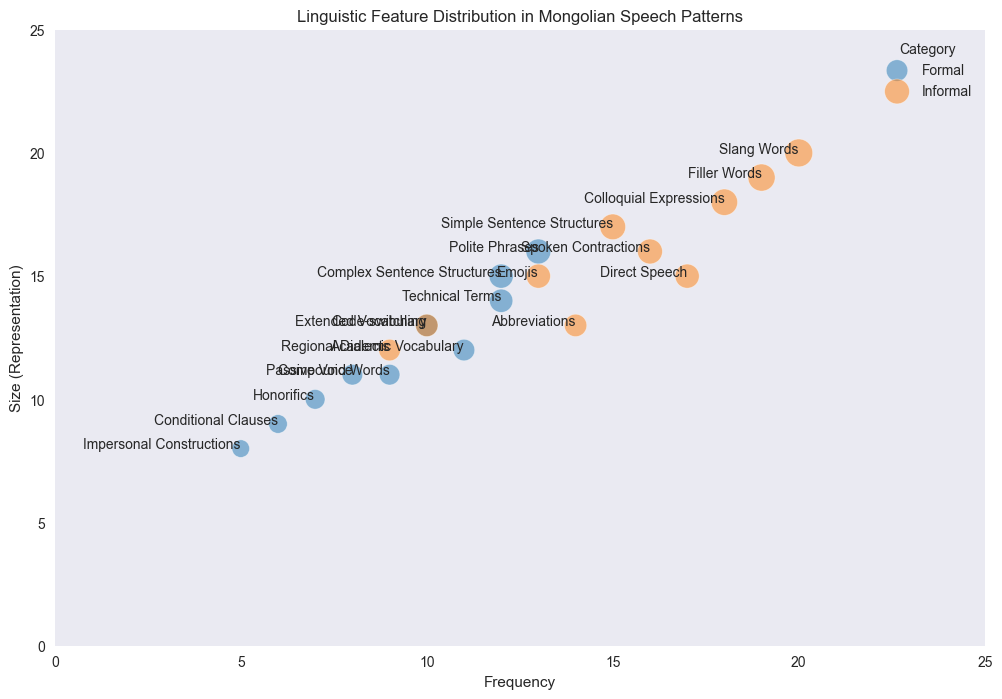Which category has features with the highest frequency? To determine this, look for the features with the highest frequency and identify their category. The highest frequencies are 20 and 19, both of which fall under the "Informal" category.
Answer: Informal What is the size representation of "Polite Phrases" in Formal speech? Locate the feature "Polite Phrases" within the Formal category, observe its size representation on the y-axis.
Answer: 16 How does the frequency of "Slang Words" compare to "Complex Sentence Structures"? Find the "Slang Words" and "Complex Sentence Structures" points and compare their positions on the x-axis. "Slang Words" has a frequency of 20, while "Complex Sentence Structures" has a frequency of 12.
Answer: Slang Words have higher frequency Which linguistic feature in Formal writing has the smallest size? In the Formal category for writing context, find the feature with the smallest value on the y-axis. "Impersonal Constructions" has the smallest size of 8.
Answer: Impersonal Constructions Between "Emojis" and "Spoken Contractions", which has higher frequency and size? Identify the points for "Emojis" and "Spoken Contractions" and compare their frequency (x-axis position) and size (bubble size). "Spoken Contractions" has a frequency of 16 and size 16, while "Emojis" has a frequency of 13 and size of 15.
Answer: Spoken Contractions Is the frequency of "Regional Dialects" greater or lesser than "Compound Words"? Compare the frequency values on the x-axis for "Regional Dialects" (9) and "Compound Words" (9). Both are the same.
Answer: Equal What is the average frequency of "Formal" linguistic features? Find all Formal category features, sum their frequencies, and divide by the number of features. Frequencies: 12, 7, 10, 8, 13, 11, 9, 12, 6, 5. Sum = 93. Number of features = 10. Average = 93/10.
Answer: 9.3 Which category, Formal or Informal, has more features with a size representation above 15? Count the number of features in each category that have a size above 15. Formal: 2 ("Complex Sentence Structures" and "Polite Phrases"). Informal: 3 ("Slang Words," "Colloquial Expressions," and "Filler Words").
Answer: Informal 